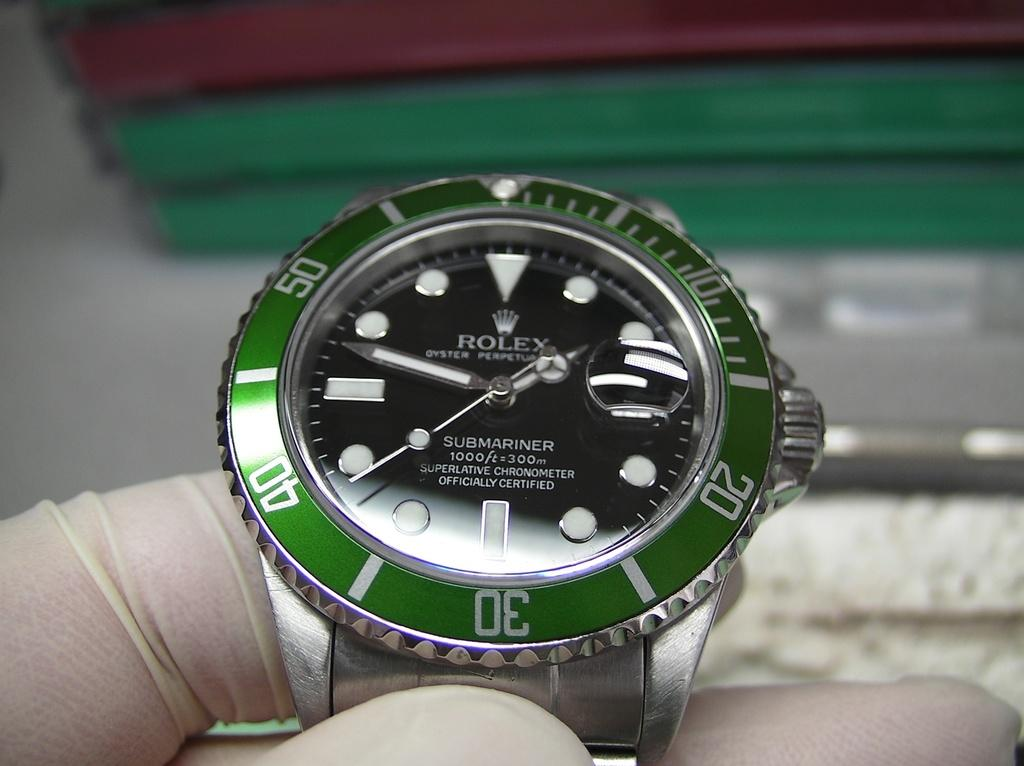<image>
Share a concise interpretation of the image provided. The time on the green trimmed watched says 1:50. 